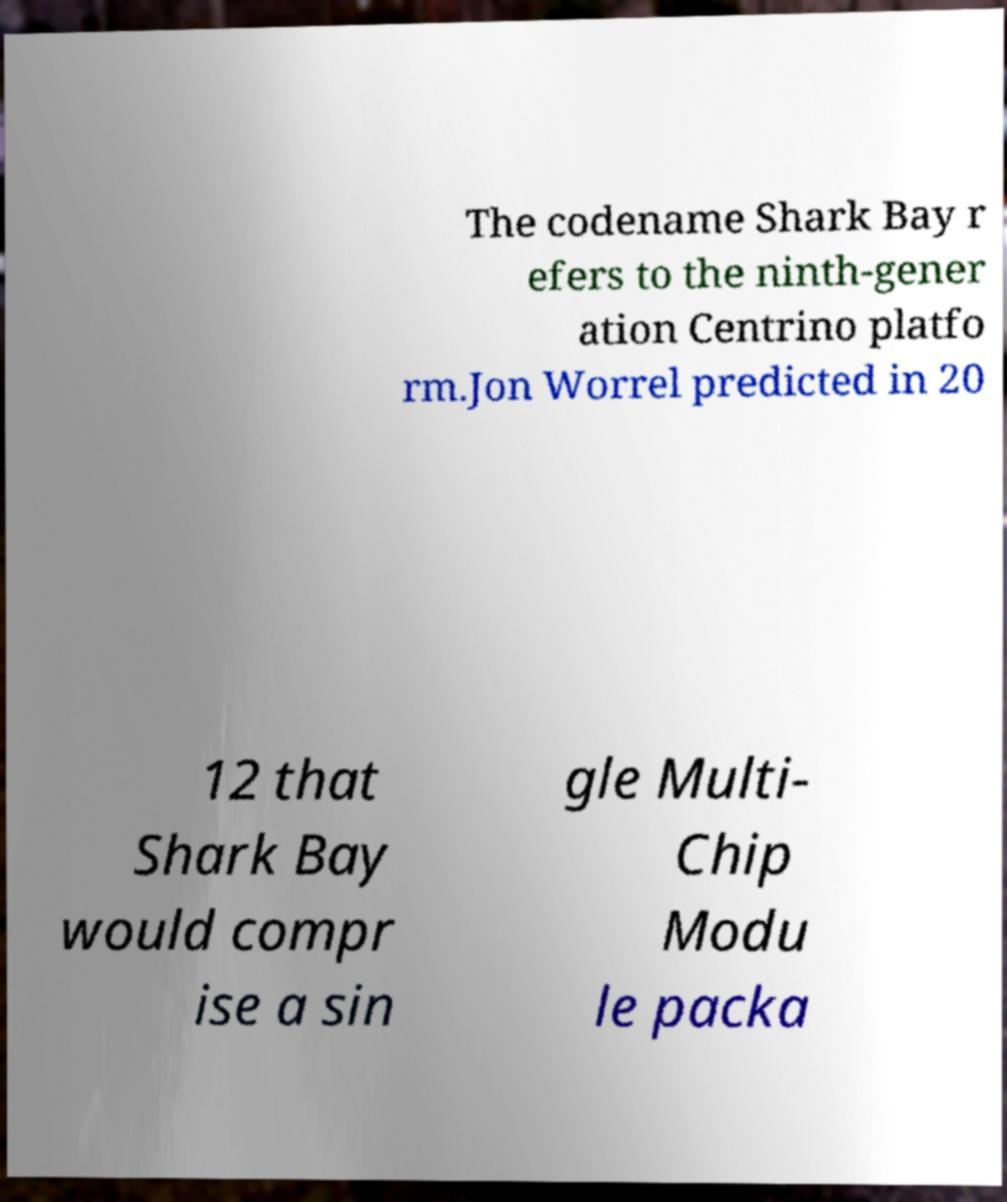I need the written content from this picture converted into text. Can you do that? The codename Shark Bay r efers to the ninth-gener ation Centrino platfo rm.Jon Worrel predicted in 20 12 that Shark Bay would compr ise a sin gle Multi- Chip Modu le packa 